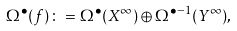<formula> <loc_0><loc_0><loc_500><loc_500>\Omega ^ { \bullet } ( f ) \colon = \Omega ^ { \bullet } ( X ^ { \infty } ) \oplus \Omega ^ { \bullet - 1 } ( Y ^ { \infty } ) ,</formula> 